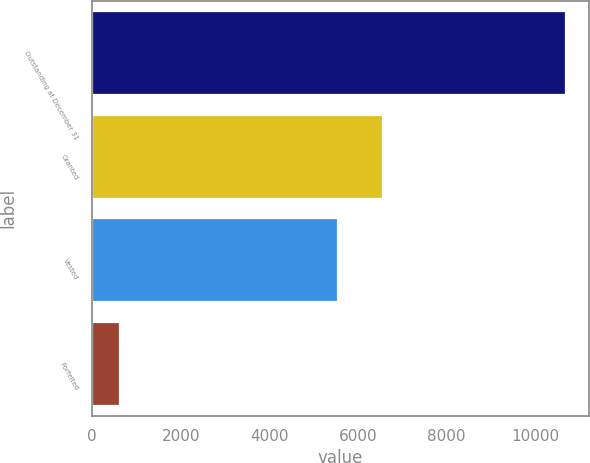Convert chart. <chart><loc_0><loc_0><loc_500><loc_500><bar_chart><fcel>Outstanding at December 31<fcel>Granted<fcel>Vested<fcel>Forfeited<nl><fcel>10682<fcel>6542.5<fcel>5532<fcel>610<nl></chart> 